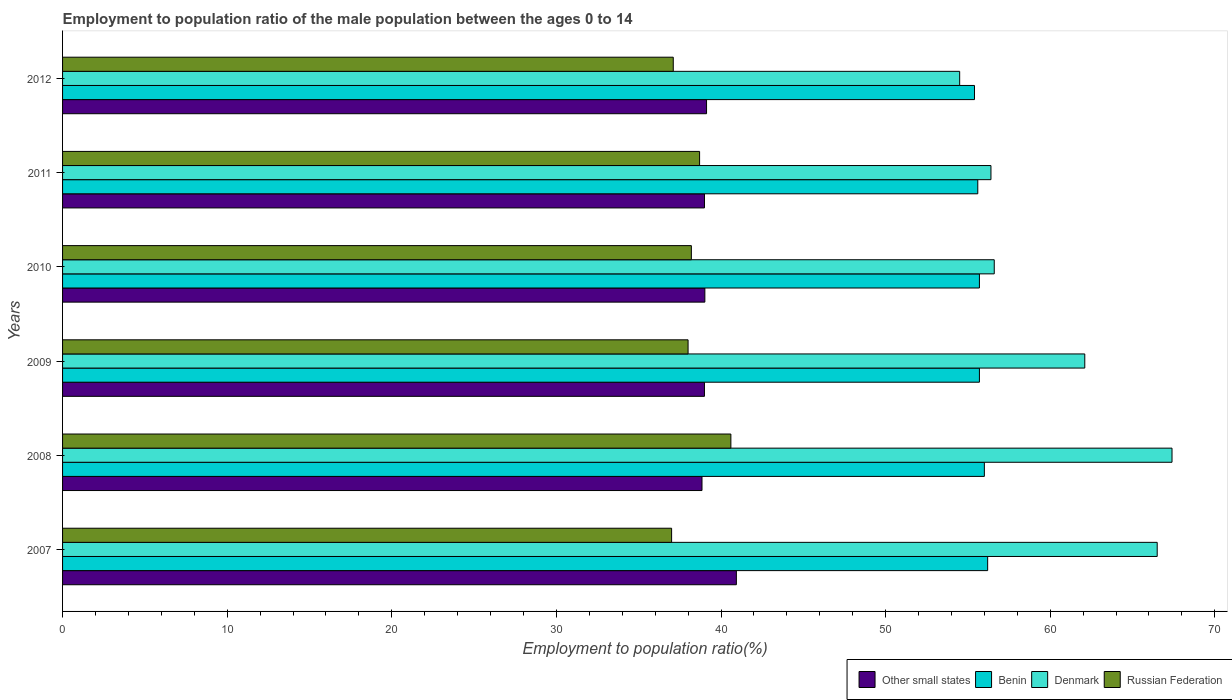Are the number of bars per tick equal to the number of legend labels?
Offer a very short reply. Yes. Are the number of bars on each tick of the Y-axis equal?
Ensure brevity in your answer.  Yes. What is the label of the 5th group of bars from the top?
Provide a short and direct response. 2008. In how many cases, is the number of bars for a given year not equal to the number of legend labels?
Provide a succinct answer. 0. What is the employment to population ratio in Benin in 2011?
Provide a short and direct response. 55.6. Across all years, what is the maximum employment to population ratio in Russian Federation?
Your answer should be compact. 40.6. Across all years, what is the minimum employment to population ratio in Benin?
Keep it short and to the point. 55.4. In which year was the employment to population ratio in Benin minimum?
Your answer should be compact. 2012. What is the total employment to population ratio in Benin in the graph?
Give a very brief answer. 334.6. What is the difference between the employment to population ratio in Other small states in 2009 and that in 2011?
Keep it short and to the point. -0. What is the difference between the employment to population ratio in Russian Federation in 2009 and the employment to population ratio in Other small states in 2012?
Your response must be concise. -1.12. What is the average employment to population ratio in Benin per year?
Provide a succinct answer. 55.77. In the year 2011, what is the difference between the employment to population ratio in Benin and employment to population ratio in Other small states?
Provide a succinct answer. 16.6. What is the ratio of the employment to population ratio in Other small states in 2007 to that in 2008?
Make the answer very short. 1.05. What is the difference between the highest and the second highest employment to population ratio in Denmark?
Make the answer very short. 0.9. What is the difference between the highest and the lowest employment to population ratio in Russian Federation?
Your answer should be compact. 3.6. What does the 2nd bar from the top in 2009 represents?
Provide a succinct answer. Denmark. What does the 2nd bar from the bottom in 2007 represents?
Ensure brevity in your answer.  Benin. Is it the case that in every year, the sum of the employment to population ratio in Denmark and employment to population ratio in Russian Federation is greater than the employment to population ratio in Benin?
Your response must be concise. Yes. Are all the bars in the graph horizontal?
Provide a succinct answer. Yes. How many years are there in the graph?
Your response must be concise. 6. What is the difference between two consecutive major ticks on the X-axis?
Ensure brevity in your answer.  10. Does the graph contain any zero values?
Provide a short and direct response. No. Does the graph contain grids?
Keep it short and to the point. No. Where does the legend appear in the graph?
Provide a succinct answer. Bottom right. How many legend labels are there?
Give a very brief answer. 4. How are the legend labels stacked?
Your answer should be compact. Horizontal. What is the title of the graph?
Give a very brief answer. Employment to population ratio of the male population between the ages 0 to 14. Does "Swaziland" appear as one of the legend labels in the graph?
Give a very brief answer. No. What is the label or title of the X-axis?
Your answer should be compact. Employment to population ratio(%). What is the Employment to population ratio(%) in Other small states in 2007?
Keep it short and to the point. 40.93. What is the Employment to population ratio(%) in Benin in 2007?
Offer a terse response. 56.2. What is the Employment to population ratio(%) in Denmark in 2007?
Give a very brief answer. 66.5. What is the Employment to population ratio(%) in Other small states in 2008?
Your answer should be very brief. 38.85. What is the Employment to population ratio(%) in Denmark in 2008?
Keep it short and to the point. 67.4. What is the Employment to population ratio(%) in Russian Federation in 2008?
Ensure brevity in your answer.  40.6. What is the Employment to population ratio(%) in Other small states in 2009?
Your answer should be very brief. 39. What is the Employment to population ratio(%) in Benin in 2009?
Offer a very short reply. 55.7. What is the Employment to population ratio(%) in Denmark in 2009?
Keep it short and to the point. 62.1. What is the Employment to population ratio(%) of Russian Federation in 2009?
Offer a terse response. 38. What is the Employment to population ratio(%) of Other small states in 2010?
Provide a succinct answer. 39.02. What is the Employment to population ratio(%) in Benin in 2010?
Offer a terse response. 55.7. What is the Employment to population ratio(%) of Denmark in 2010?
Keep it short and to the point. 56.6. What is the Employment to population ratio(%) in Russian Federation in 2010?
Give a very brief answer. 38.2. What is the Employment to population ratio(%) of Other small states in 2011?
Provide a succinct answer. 39. What is the Employment to population ratio(%) of Benin in 2011?
Give a very brief answer. 55.6. What is the Employment to population ratio(%) in Denmark in 2011?
Your answer should be compact. 56.4. What is the Employment to population ratio(%) in Russian Federation in 2011?
Give a very brief answer. 38.7. What is the Employment to population ratio(%) in Other small states in 2012?
Your answer should be compact. 39.12. What is the Employment to population ratio(%) of Benin in 2012?
Provide a short and direct response. 55.4. What is the Employment to population ratio(%) of Denmark in 2012?
Your response must be concise. 54.5. What is the Employment to population ratio(%) in Russian Federation in 2012?
Give a very brief answer. 37.1. Across all years, what is the maximum Employment to population ratio(%) of Other small states?
Your answer should be very brief. 40.93. Across all years, what is the maximum Employment to population ratio(%) in Benin?
Ensure brevity in your answer.  56.2. Across all years, what is the maximum Employment to population ratio(%) of Denmark?
Your answer should be compact. 67.4. Across all years, what is the maximum Employment to population ratio(%) of Russian Federation?
Ensure brevity in your answer.  40.6. Across all years, what is the minimum Employment to population ratio(%) in Other small states?
Provide a succinct answer. 38.85. Across all years, what is the minimum Employment to population ratio(%) in Benin?
Offer a terse response. 55.4. Across all years, what is the minimum Employment to population ratio(%) in Denmark?
Provide a succinct answer. 54.5. Across all years, what is the minimum Employment to population ratio(%) in Russian Federation?
Provide a succinct answer. 37. What is the total Employment to population ratio(%) in Other small states in the graph?
Your answer should be very brief. 235.91. What is the total Employment to population ratio(%) of Benin in the graph?
Offer a terse response. 334.6. What is the total Employment to population ratio(%) in Denmark in the graph?
Provide a short and direct response. 363.5. What is the total Employment to population ratio(%) in Russian Federation in the graph?
Your answer should be compact. 229.6. What is the difference between the Employment to population ratio(%) of Other small states in 2007 and that in 2008?
Give a very brief answer. 2.09. What is the difference between the Employment to population ratio(%) of Benin in 2007 and that in 2008?
Offer a very short reply. 0.2. What is the difference between the Employment to population ratio(%) in Denmark in 2007 and that in 2008?
Offer a very short reply. -0.9. What is the difference between the Employment to population ratio(%) of Russian Federation in 2007 and that in 2008?
Make the answer very short. -3.6. What is the difference between the Employment to population ratio(%) of Other small states in 2007 and that in 2009?
Make the answer very short. 1.94. What is the difference between the Employment to population ratio(%) of Russian Federation in 2007 and that in 2009?
Give a very brief answer. -1. What is the difference between the Employment to population ratio(%) in Other small states in 2007 and that in 2010?
Your answer should be very brief. 1.91. What is the difference between the Employment to population ratio(%) of Benin in 2007 and that in 2010?
Your answer should be very brief. 0.5. What is the difference between the Employment to population ratio(%) of Other small states in 2007 and that in 2011?
Keep it short and to the point. 1.94. What is the difference between the Employment to population ratio(%) in Russian Federation in 2007 and that in 2011?
Offer a very short reply. -1.7. What is the difference between the Employment to population ratio(%) of Other small states in 2007 and that in 2012?
Offer a very short reply. 1.81. What is the difference between the Employment to population ratio(%) of Denmark in 2007 and that in 2012?
Offer a terse response. 12. What is the difference between the Employment to population ratio(%) in Russian Federation in 2007 and that in 2012?
Your answer should be compact. -0.1. What is the difference between the Employment to population ratio(%) of Other small states in 2008 and that in 2009?
Provide a succinct answer. -0.15. What is the difference between the Employment to population ratio(%) in Benin in 2008 and that in 2009?
Offer a terse response. 0.3. What is the difference between the Employment to population ratio(%) in Russian Federation in 2008 and that in 2009?
Offer a very short reply. 2.6. What is the difference between the Employment to population ratio(%) in Other small states in 2008 and that in 2010?
Offer a terse response. -0.17. What is the difference between the Employment to population ratio(%) of Other small states in 2008 and that in 2011?
Offer a terse response. -0.15. What is the difference between the Employment to population ratio(%) in Benin in 2008 and that in 2011?
Give a very brief answer. 0.4. What is the difference between the Employment to population ratio(%) in Other small states in 2008 and that in 2012?
Give a very brief answer. -0.28. What is the difference between the Employment to population ratio(%) in Russian Federation in 2008 and that in 2012?
Your response must be concise. 3.5. What is the difference between the Employment to population ratio(%) of Other small states in 2009 and that in 2010?
Keep it short and to the point. -0.02. What is the difference between the Employment to population ratio(%) of Benin in 2009 and that in 2010?
Your answer should be very brief. 0. What is the difference between the Employment to population ratio(%) in Denmark in 2009 and that in 2010?
Give a very brief answer. 5.5. What is the difference between the Employment to population ratio(%) in Russian Federation in 2009 and that in 2010?
Make the answer very short. -0.2. What is the difference between the Employment to population ratio(%) of Other small states in 2009 and that in 2011?
Your answer should be compact. -0. What is the difference between the Employment to population ratio(%) of Other small states in 2009 and that in 2012?
Keep it short and to the point. -0.13. What is the difference between the Employment to population ratio(%) of Benin in 2009 and that in 2012?
Offer a terse response. 0.3. What is the difference between the Employment to population ratio(%) in Other small states in 2010 and that in 2011?
Provide a short and direct response. 0.02. What is the difference between the Employment to population ratio(%) in Benin in 2010 and that in 2011?
Provide a short and direct response. 0.1. What is the difference between the Employment to population ratio(%) of Denmark in 2010 and that in 2011?
Ensure brevity in your answer.  0.2. What is the difference between the Employment to population ratio(%) of Other small states in 2010 and that in 2012?
Provide a short and direct response. -0.1. What is the difference between the Employment to population ratio(%) in Other small states in 2011 and that in 2012?
Your response must be concise. -0.12. What is the difference between the Employment to population ratio(%) of Benin in 2011 and that in 2012?
Give a very brief answer. 0.2. What is the difference between the Employment to population ratio(%) of Denmark in 2011 and that in 2012?
Provide a short and direct response. 1.9. What is the difference between the Employment to population ratio(%) of Other small states in 2007 and the Employment to population ratio(%) of Benin in 2008?
Keep it short and to the point. -15.07. What is the difference between the Employment to population ratio(%) in Other small states in 2007 and the Employment to population ratio(%) in Denmark in 2008?
Your answer should be compact. -26.47. What is the difference between the Employment to population ratio(%) of Other small states in 2007 and the Employment to population ratio(%) of Russian Federation in 2008?
Offer a terse response. 0.33. What is the difference between the Employment to population ratio(%) in Benin in 2007 and the Employment to population ratio(%) in Russian Federation in 2008?
Keep it short and to the point. 15.6. What is the difference between the Employment to population ratio(%) in Denmark in 2007 and the Employment to population ratio(%) in Russian Federation in 2008?
Keep it short and to the point. 25.9. What is the difference between the Employment to population ratio(%) of Other small states in 2007 and the Employment to population ratio(%) of Benin in 2009?
Make the answer very short. -14.77. What is the difference between the Employment to population ratio(%) of Other small states in 2007 and the Employment to population ratio(%) of Denmark in 2009?
Offer a very short reply. -21.17. What is the difference between the Employment to population ratio(%) of Other small states in 2007 and the Employment to population ratio(%) of Russian Federation in 2009?
Your answer should be compact. 2.93. What is the difference between the Employment to population ratio(%) in Benin in 2007 and the Employment to population ratio(%) in Denmark in 2009?
Provide a succinct answer. -5.9. What is the difference between the Employment to population ratio(%) in Benin in 2007 and the Employment to population ratio(%) in Russian Federation in 2009?
Keep it short and to the point. 18.2. What is the difference between the Employment to population ratio(%) of Other small states in 2007 and the Employment to population ratio(%) of Benin in 2010?
Give a very brief answer. -14.77. What is the difference between the Employment to population ratio(%) of Other small states in 2007 and the Employment to population ratio(%) of Denmark in 2010?
Your response must be concise. -15.67. What is the difference between the Employment to population ratio(%) in Other small states in 2007 and the Employment to population ratio(%) in Russian Federation in 2010?
Provide a short and direct response. 2.73. What is the difference between the Employment to population ratio(%) of Benin in 2007 and the Employment to population ratio(%) of Denmark in 2010?
Offer a terse response. -0.4. What is the difference between the Employment to population ratio(%) of Benin in 2007 and the Employment to population ratio(%) of Russian Federation in 2010?
Your answer should be very brief. 18. What is the difference between the Employment to population ratio(%) in Denmark in 2007 and the Employment to population ratio(%) in Russian Federation in 2010?
Give a very brief answer. 28.3. What is the difference between the Employment to population ratio(%) in Other small states in 2007 and the Employment to population ratio(%) in Benin in 2011?
Your answer should be compact. -14.67. What is the difference between the Employment to population ratio(%) of Other small states in 2007 and the Employment to population ratio(%) of Denmark in 2011?
Provide a short and direct response. -15.47. What is the difference between the Employment to population ratio(%) of Other small states in 2007 and the Employment to population ratio(%) of Russian Federation in 2011?
Ensure brevity in your answer.  2.23. What is the difference between the Employment to population ratio(%) in Benin in 2007 and the Employment to population ratio(%) in Denmark in 2011?
Provide a short and direct response. -0.2. What is the difference between the Employment to population ratio(%) of Denmark in 2007 and the Employment to population ratio(%) of Russian Federation in 2011?
Offer a very short reply. 27.8. What is the difference between the Employment to population ratio(%) of Other small states in 2007 and the Employment to population ratio(%) of Benin in 2012?
Your response must be concise. -14.47. What is the difference between the Employment to population ratio(%) in Other small states in 2007 and the Employment to population ratio(%) in Denmark in 2012?
Provide a short and direct response. -13.57. What is the difference between the Employment to population ratio(%) of Other small states in 2007 and the Employment to population ratio(%) of Russian Federation in 2012?
Your answer should be very brief. 3.83. What is the difference between the Employment to population ratio(%) in Benin in 2007 and the Employment to population ratio(%) in Denmark in 2012?
Provide a short and direct response. 1.7. What is the difference between the Employment to population ratio(%) of Denmark in 2007 and the Employment to population ratio(%) of Russian Federation in 2012?
Give a very brief answer. 29.4. What is the difference between the Employment to population ratio(%) in Other small states in 2008 and the Employment to population ratio(%) in Benin in 2009?
Your answer should be very brief. -16.85. What is the difference between the Employment to population ratio(%) in Other small states in 2008 and the Employment to population ratio(%) in Denmark in 2009?
Make the answer very short. -23.25. What is the difference between the Employment to population ratio(%) of Other small states in 2008 and the Employment to population ratio(%) of Russian Federation in 2009?
Your response must be concise. 0.85. What is the difference between the Employment to population ratio(%) in Benin in 2008 and the Employment to population ratio(%) in Denmark in 2009?
Keep it short and to the point. -6.1. What is the difference between the Employment to population ratio(%) in Denmark in 2008 and the Employment to population ratio(%) in Russian Federation in 2009?
Make the answer very short. 29.4. What is the difference between the Employment to population ratio(%) of Other small states in 2008 and the Employment to population ratio(%) of Benin in 2010?
Offer a very short reply. -16.85. What is the difference between the Employment to population ratio(%) of Other small states in 2008 and the Employment to population ratio(%) of Denmark in 2010?
Provide a succinct answer. -17.75. What is the difference between the Employment to population ratio(%) of Other small states in 2008 and the Employment to population ratio(%) of Russian Federation in 2010?
Your response must be concise. 0.65. What is the difference between the Employment to population ratio(%) of Denmark in 2008 and the Employment to population ratio(%) of Russian Federation in 2010?
Give a very brief answer. 29.2. What is the difference between the Employment to population ratio(%) of Other small states in 2008 and the Employment to population ratio(%) of Benin in 2011?
Keep it short and to the point. -16.75. What is the difference between the Employment to population ratio(%) in Other small states in 2008 and the Employment to population ratio(%) in Denmark in 2011?
Give a very brief answer. -17.55. What is the difference between the Employment to population ratio(%) of Other small states in 2008 and the Employment to population ratio(%) of Russian Federation in 2011?
Keep it short and to the point. 0.15. What is the difference between the Employment to population ratio(%) of Benin in 2008 and the Employment to population ratio(%) of Russian Federation in 2011?
Offer a very short reply. 17.3. What is the difference between the Employment to population ratio(%) of Denmark in 2008 and the Employment to population ratio(%) of Russian Federation in 2011?
Provide a succinct answer. 28.7. What is the difference between the Employment to population ratio(%) of Other small states in 2008 and the Employment to population ratio(%) of Benin in 2012?
Provide a succinct answer. -16.55. What is the difference between the Employment to population ratio(%) of Other small states in 2008 and the Employment to population ratio(%) of Denmark in 2012?
Your answer should be very brief. -15.65. What is the difference between the Employment to population ratio(%) in Other small states in 2008 and the Employment to population ratio(%) in Russian Federation in 2012?
Your answer should be compact. 1.75. What is the difference between the Employment to population ratio(%) of Benin in 2008 and the Employment to population ratio(%) of Denmark in 2012?
Your answer should be compact. 1.5. What is the difference between the Employment to population ratio(%) of Benin in 2008 and the Employment to population ratio(%) of Russian Federation in 2012?
Give a very brief answer. 18.9. What is the difference between the Employment to population ratio(%) of Denmark in 2008 and the Employment to population ratio(%) of Russian Federation in 2012?
Your answer should be very brief. 30.3. What is the difference between the Employment to population ratio(%) in Other small states in 2009 and the Employment to population ratio(%) in Benin in 2010?
Offer a very short reply. -16.7. What is the difference between the Employment to population ratio(%) in Other small states in 2009 and the Employment to population ratio(%) in Denmark in 2010?
Provide a short and direct response. -17.6. What is the difference between the Employment to population ratio(%) of Other small states in 2009 and the Employment to population ratio(%) of Russian Federation in 2010?
Your response must be concise. 0.8. What is the difference between the Employment to population ratio(%) in Benin in 2009 and the Employment to population ratio(%) in Denmark in 2010?
Provide a short and direct response. -0.9. What is the difference between the Employment to population ratio(%) in Denmark in 2009 and the Employment to population ratio(%) in Russian Federation in 2010?
Provide a short and direct response. 23.9. What is the difference between the Employment to population ratio(%) of Other small states in 2009 and the Employment to population ratio(%) of Benin in 2011?
Keep it short and to the point. -16.6. What is the difference between the Employment to population ratio(%) of Other small states in 2009 and the Employment to population ratio(%) of Denmark in 2011?
Ensure brevity in your answer.  -17.4. What is the difference between the Employment to population ratio(%) of Other small states in 2009 and the Employment to population ratio(%) of Russian Federation in 2011?
Provide a succinct answer. 0.3. What is the difference between the Employment to population ratio(%) of Benin in 2009 and the Employment to population ratio(%) of Denmark in 2011?
Your response must be concise. -0.7. What is the difference between the Employment to population ratio(%) in Denmark in 2009 and the Employment to population ratio(%) in Russian Federation in 2011?
Make the answer very short. 23.4. What is the difference between the Employment to population ratio(%) in Other small states in 2009 and the Employment to population ratio(%) in Benin in 2012?
Ensure brevity in your answer.  -16.4. What is the difference between the Employment to population ratio(%) in Other small states in 2009 and the Employment to population ratio(%) in Denmark in 2012?
Offer a very short reply. -15.5. What is the difference between the Employment to population ratio(%) in Other small states in 2009 and the Employment to population ratio(%) in Russian Federation in 2012?
Provide a succinct answer. 1.9. What is the difference between the Employment to population ratio(%) in Denmark in 2009 and the Employment to population ratio(%) in Russian Federation in 2012?
Provide a short and direct response. 25. What is the difference between the Employment to population ratio(%) of Other small states in 2010 and the Employment to population ratio(%) of Benin in 2011?
Keep it short and to the point. -16.58. What is the difference between the Employment to population ratio(%) in Other small states in 2010 and the Employment to population ratio(%) in Denmark in 2011?
Your answer should be very brief. -17.38. What is the difference between the Employment to population ratio(%) in Other small states in 2010 and the Employment to population ratio(%) in Russian Federation in 2011?
Ensure brevity in your answer.  0.32. What is the difference between the Employment to population ratio(%) of Benin in 2010 and the Employment to population ratio(%) of Denmark in 2011?
Give a very brief answer. -0.7. What is the difference between the Employment to population ratio(%) of Benin in 2010 and the Employment to population ratio(%) of Russian Federation in 2011?
Ensure brevity in your answer.  17. What is the difference between the Employment to population ratio(%) in Denmark in 2010 and the Employment to population ratio(%) in Russian Federation in 2011?
Provide a short and direct response. 17.9. What is the difference between the Employment to population ratio(%) in Other small states in 2010 and the Employment to population ratio(%) in Benin in 2012?
Ensure brevity in your answer.  -16.38. What is the difference between the Employment to population ratio(%) in Other small states in 2010 and the Employment to population ratio(%) in Denmark in 2012?
Ensure brevity in your answer.  -15.48. What is the difference between the Employment to population ratio(%) in Other small states in 2010 and the Employment to population ratio(%) in Russian Federation in 2012?
Keep it short and to the point. 1.92. What is the difference between the Employment to population ratio(%) in Benin in 2010 and the Employment to population ratio(%) in Denmark in 2012?
Make the answer very short. 1.2. What is the difference between the Employment to population ratio(%) in Benin in 2010 and the Employment to population ratio(%) in Russian Federation in 2012?
Give a very brief answer. 18.6. What is the difference between the Employment to population ratio(%) in Denmark in 2010 and the Employment to population ratio(%) in Russian Federation in 2012?
Provide a short and direct response. 19.5. What is the difference between the Employment to population ratio(%) of Other small states in 2011 and the Employment to population ratio(%) of Benin in 2012?
Provide a succinct answer. -16.4. What is the difference between the Employment to population ratio(%) in Other small states in 2011 and the Employment to population ratio(%) in Denmark in 2012?
Make the answer very short. -15.5. What is the difference between the Employment to population ratio(%) of Other small states in 2011 and the Employment to population ratio(%) of Russian Federation in 2012?
Provide a succinct answer. 1.9. What is the difference between the Employment to population ratio(%) in Benin in 2011 and the Employment to population ratio(%) in Denmark in 2012?
Your answer should be very brief. 1.1. What is the difference between the Employment to population ratio(%) in Denmark in 2011 and the Employment to population ratio(%) in Russian Federation in 2012?
Make the answer very short. 19.3. What is the average Employment to population ratio(%) of Other small states per year?
Offer a very short reply. 39.32. What is the average Employment to population ratio(%) in Benin per year?
Keep it short and to the point. 55.77. What is the average Employment to population ratio(%) of Denmark per year?
Your answer should be compact. 60.58. What is the average Employment to population ratio(%) of Russian Federation per year?
Your answer should be compact. 38.27. In the year 2007, what is the difference between the Employment to population ratio(%) of Other small states and Employment to population ratio(%) of Benin?
Ensure brevity in your answer.  -15.27. In the year 2007, what is the difference between the Employment to population ratio(%) of Other small states and Employment to population ratio(%) of Denmark?
Provide a short and direct response. -25.57. In the year 2007, what is the difference between the Employment to population ratio(%) of Other small states and Employment to population ratio(%) of Russian Federation?
Your response must be concise. 3.93. In the year 2007, what is the difference between the Employment to population ratio(%) in Denmark and Employment to population ratio(%) in Russian Federation?
Your answer should be compact. 29.5. In the year 2008, what is the difference between the Employment to population ratio(%) in Other small states and Employment to population ratio(%) in Benin?
Give a very brief answer. -17.15. In the year 2008, what is the difference between the Employment to population ratio(%) in Other small states and Employment to population ratio(%) in Denmark?
Ensure brevity in your answer.  -28.55. In the year 2008, what is the difference between the Employment to population ratio(%) of Other small states and Employment to population ratio(%) of Russian Federation?
Offer a terse response. -1.75. In the year 2008, what is the difference between the Employment to population ratio(%) of Benin and Employment to population ratio(%) of Denmark?
Your answer should be compact. -11.4. In the year 2008, what is the difference between the Employment to population ratio(%) in Denmark and Employment to population ratio(%) in Russian Federation?
Provide a succinct answer. 26.8. In the year 2009, what is the difference between the Employment to population ratio(%) of Other small states and Employment to population ratio(%) of Benin?
Your response must be concise. -16.7. In the year 2009, what is the difference between the Employment to population ratio(%) of Other small states and Employment to population ratio(%) of Denmark?
Give a very brief answer. -23.1. In the year 2009, what is the difference between the Employment to population ratio(%) in Other small states and Employment to population ratio(%) in Russian Federation?
Offer a very short reply. 1. In the year 2009, what is the difference between the Employment to population ratio(%) in Benin and Employment to population ratio(%) in Russian Federation?
Your response must be concise. 17.7. In the year 2009, what is the difference between the Employment to population ratio(%) in Denmark and Employment to population ratio(%) in Russian Federation?
Offer a very short reply. 24.1. In the year 2010, what is the difference between the Employment to population ratio(%) in Other small states and Employment to population ratio(%) in Benin?
Provide a short and direct response. -16.68. In the year 2010, what is the difference between the Employment to population ratio(%) in Other small states and Employment to population ratio(%) in Denmark?
Make the answer very short. -17.58. In the year 2010, what is the difference between the Employment to population ratio(%) of Other small states and Employment to population ratio(%) of Russian Federation?
Your answer should be very brief. 0.82. In the year 2010, what is the difference between the Employment to population ratio(%) of Benin and Employment to population ratio(%) of Denmark?
Make the answer very short. -0.9. In the year 2010, what is the difference between the Employment to population ratio(%) of Denmark and Employment to population ratio(%) of Russian Federation?
Offer a very short reply. 18.4. In the year 2011, what is the difference between the Employment to population ratio(%) in Other small states and Employment to population ratio(%) in Benin?
Your answer should be compact. -16.6. In the year 2011, what is the difference between the Employment to population ratio(%) of Other small states and Employment to population ratio(%) of Denmark?
Offer a very short reply. -17.4. In the year 2011, what is the difference between the Employment to population ratio(%) in Other small states and Employment to population ratio(%) in Russian Federation?
Your response must be concise. 0.3. In the year 2012, what is the difference between the Employment to population ratio(%) in Other small states and Employment to population ratio(%) in Benin?
Offer a very short reply. -16.28. In the year 2012, what is the difference between the Employment to population ratio(%) in Other small states and Employment to population ratio(%) in Denmark?
Give a very brief answer. -15.38. In the year 2012, what is the difference between the Employment to population ratio(%) in Other small states and Employment to population ratio(%) in Russian Federation?
Offer a terse response. 2.02. What is the ratio of the Employment to population ratio(%) of Other small states in 2007 to that in 2008?
Offer a very short reply. 1.05. What is the ratio of the Employment to population ratio(%) of Benin in 2007 to that in 2008?
Provide a succinct answer. 1. What is the ratio of the Employment to population ratio(%) of Denmark in 2007 to that in 2008?
Your response must be concise. 0.99. What is the ratio of the Employment to population ratio(%) of Russian Federation in 2007 to that in 2008?
Keep it short and to the point. 0.91. What is the ratio of the Employment to population ratio(%) in Other small states in 2007 to that in 2009?
Offer a very short reply. 1.05. What is the ratio of the Employment to population ratio(%) in Denmark in 2007 to that in 2009?
Provide a succinct answer. 1.07. What is the ratio of the Employment to population ratio(%) in Russian Federation in 2007 to that in 2009?
Your answer should be very brief. 0.97. What is the ratio of the Employment to population ratio(%) of Other small states in 2007 to that in 2010?
Your response must be concise. 1.05. What is the ratio of the Employment to population ratio(%) in Benin in 2007 to that in 2010?
Offer a very short reply. 1.01. What is the ratio of the Employment to population ratio(%) in Denmark in 2007 to that in 2010?
Your answer should be compact. 1.17. What is the ratio of the Employment to population ratio(%) of Russian Federation in 2007 to that in 2010?
Provide a short and direct response. 0.97. What is the ratio of the Employment to population ratio(%) of Other small states in 2007 to that in 2011?
Ensure brevity in your answer.  1.05. What is the ratio of the Employment to population ratio(%) of Benin in 2007 to that in 2011?
Your answer should be compact. 1.01. What is the ratio of the Employment to population ratio(%) of Denmark in 2007 to that in 2011?
Make the answer very short. 1.18. What is the ratio of the Employment to population ratio(%) of Russian Federation in 2007 to that in 2011?
Keep it short and to the point. 0.96. What is the ratio of the Employment to population ratio(%) in Other small states in 2007 to that in 2012?
Offer a very short reply. 1.05. What is the ratio of the Employment to population ratio(%) in Benin in 2007 to that in 2012?
Keep it short and to the point. 1.01. What is the ratio of the Employment to population ratio(%) in Denmark in 2007 to that in 2012?
Ensure brevity in your answer.  1.22. What is the ratio of the Employment to population ratio(%) in Benin in 2008 to that in 2009?
Keep it short and to the point. 1.01. What is the ratio of the Employment to population ratio(%) in Denmark in 2008 to that in 2009?
Your answer should be compact. 1.09. What is the ratio of the Employment to population ratio(%) of Russian Federation in 2008 to that in 2009?
Make the answer very short. 1.07. What is the ratio of the Employment to population ratio(%) of Other small states in 2008 to that in 2010?
Keep it short and to the point. 1. What is the ratio of the Employment to population ratio(%) in Benin in 2008 to that in 2010?
Give a very brief answer. 1.01. What is the ratio of the Employment to population ratio(%) in Denmark in 2008 to that in 2010?
Offer a very short reply. 1.19. What is the ratio of the Employment to population ratio(%) of Russian Federation in 2008 to that in 2010?
Your answer should be compact. 1.06. What is the ratio of the Employment to population ratio(%) in Denmark in 2008 to that in 2011?
Give a very brief answer. 1.2. What is the ratio of the Employment to population ratio(%) of Russian Federation in 2008 to that in 2011?
Your answer should be very brief. 1.05. What is the ratio of the Employment to population ratio(%) in Benin in 2008 to that in 2012?
Make the answer very short. 1.01. What is the ratio of the Employment to population ratio(%) in Denmark in 2008 to that in 2012?
Offer a very short reply. 1.24. What is the ratio of the Employment to population ratio(%) in Russian Federation in 2008 to that in 2012?
Your response must be concise. 1.09. What is the ratio of the Employment to population ratio(%) of Other small states in 2009 to that in 2010?
Give a very brief answer. 1. What is the ratio of the Employment to population ratio(%) of Denmark in 2009 to that in 2010?
Your response must be concise. 1.1. What is the ratio of the Employment to population ratio(%) of Benin in 2009 to that in 2011?
Your answer should be compact. 1. What is the ratio of the Employment to population ratio(%) in Denmark in 2009 to that in 2011?
Provide a short and direct response. 1.1. What is the ratio of the Employment to population ratio(%) of Russian Federation in 2009 to that in 2011?
Your answer should be compact. 0.98. What is the ratio of the Employment to population ratio(%) in Other small states in 2009 to that in 2012?
Your response must be concise. 1. What is the ratio of the Employment to population ratio(%) in Benin in 2009 to that in 2012?
Your response must be concise. 1.01. What is the ratio of the Employment to population ratio(%) of Denmark in 2009 to that in 2012?
Your answer should be very brief. 1.14. What is the ratio of the Employment to population ratio(%) of Russian Federation in 2009 to that in 2012?
Provide a short and direct response. 1.02. What is the ratio of the Employment to population ratio(%) in Other small states in 2010 to that in 2011?
Your response must be concise. 1. What is the ratio of the Employment to population ratio(%) of Russian Federation in 2010 to that in 2011?
Ensure brevity in your answer.  0.99. What is the ratio of the Employment to population ratio(%) in Benin in 2010 to that in 2012?
Provide a succinct answer. 1.01. What is the ratio of the Employment to population ratio(%) of Russian Federation in 2010 to that in 2012?
Your response must be concise. 1.03. What is the ratio of the Employment to population ratio(%) of Denmark in 2011 to that in 2012?
Make the answer very short. 1.03. What is the ratio of the Employment to population ratio(%) in Russian Federation in 2011 to that in 2012?
Offer a terse response. 1.04. What is the difference between the highest and the second highest Employment to population ratio(%) of Other small states?
Provide a succinct answer. 1.81. What is the difference between the highest and the second highest Employment to population ratio(%) in Denmark?
Provide a succinct answer. 0.9. What is the difference between the highest and the lowest Employment to population ratio(%) of Other small states?
Your answer should be very brief. 2.09. What is the difference between the highest and the lowest Employment to population ratio(%) in Russian Federation?
Provide a short and direct response. 3.6. 